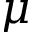Convert formula to latex. <formula><loc_0><loc_0><loc_500><loc_500>\mu</formula> 